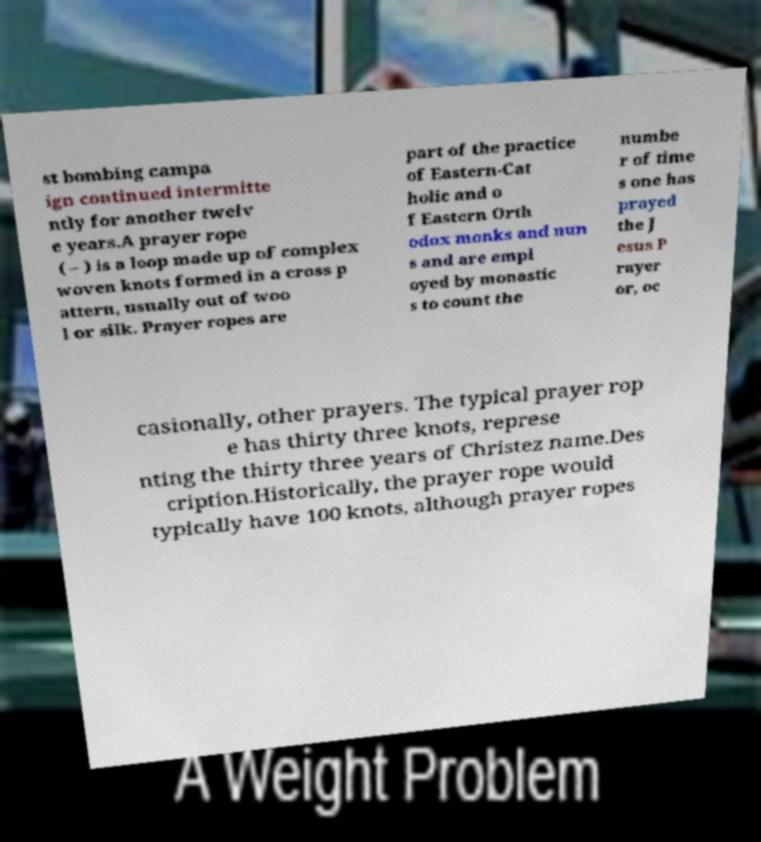There's text embedded in this image that I need extracted. Can you transcribe it verbatim? st bombing campa ign continued intermitte ntly for another twelv e years.A prayer rope ( – ) is a loop made up of complex woven knots formed in a cross p attern, usually out of woo l or silk. Prayer ropes are part of the practice of Eastern-Cat holic and o f Eastern Orth odox monks and nun s and are empl oyed by monastic s to count the numbe r of time s one has prayed the J esus P rayer or, oc casionally, other prayers. The typical prayer rop e has thirty three knots, represe nting the thirty three years of Christez name.Des cription.Historically, the prayer rope would typically have 100 knots, although prayer ropes 